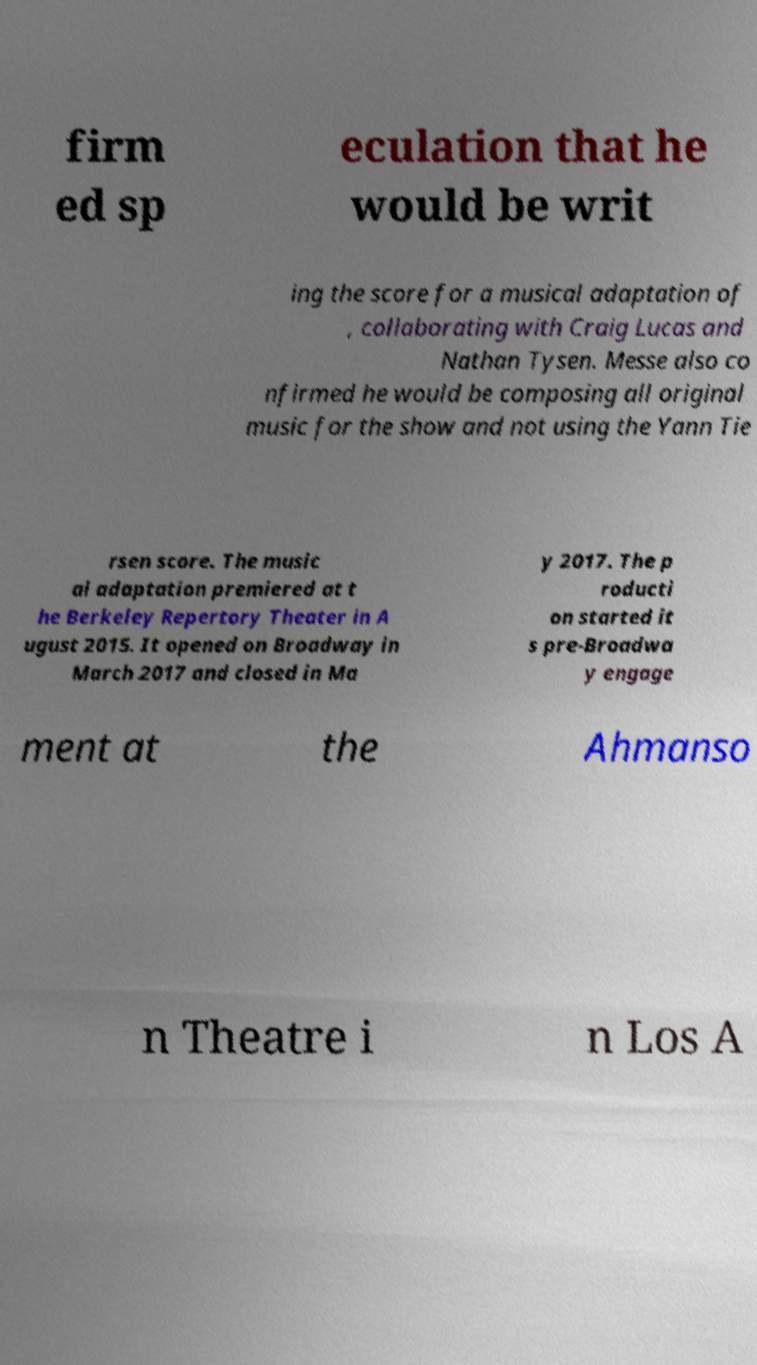Please identify and transcribe the text found in this image. firm ed sp eculation that he would be writ ing the score for a musical adaptation of , collaborating with Craig Lucas and Nathan Tysen. Messe also co nfirmed he would be composing all original music for the show and not using the Yann Tie rsen score. The music al adaptation premiered at t he Berkeley Repertory Theater in A ugust 2015. It opened on Broadway in March 2017 and closed in Ma y 2017. The p roducti on started it s pre-Broadwa y engage ment at the Ahmanso n Theatre i n Los A 